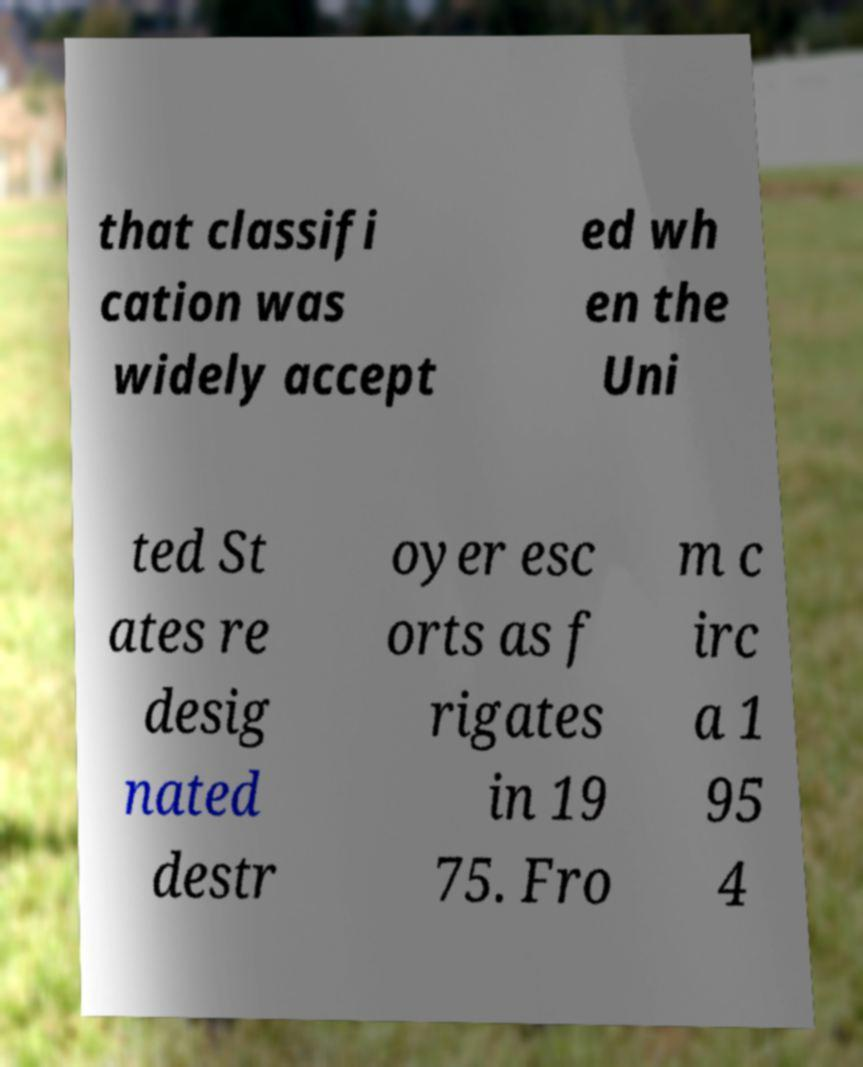Can you read and provide the text displayed in the image?This photo seems to have some interesting text. Can you extract and type it out for me? that classifi cation was widely accept ed wh en the Uni ted St ates re desig nated destr oyer esc orts as f rigates in 19 75. Fro m c irc a 1 95 4 